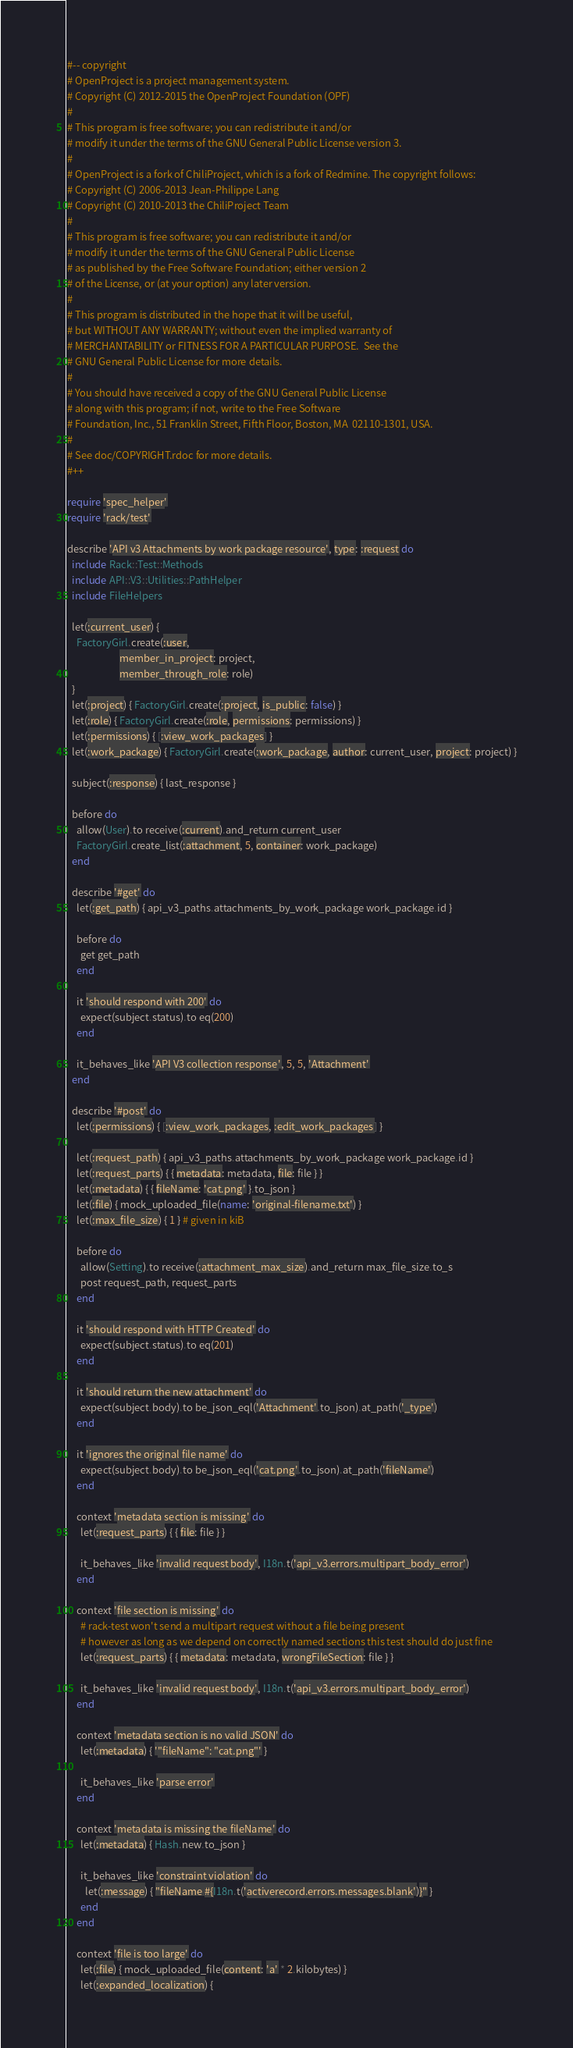<code> <loc_0><loc_0><loc_500><loc_500><_Ruby_>#-- copyright
# OpenProject is a project management system.
# Copyright (C) 2012-2015 the OpenProject Foundation (OPF)
#
# This program is free software; you can redistribute it and/or
# modify it under the terms of the GNU General Public License version 3.
#
# OpenProject is a fork of ChiliProject, which is a fork of Redmine. The copyright follows:
# Copyright (C) 2006-2013 Jean-Philippe Lang
# Copyright (C) 2010-2013 the ChiliProject Team
#
# This program is free software; you can redistribute it and/or
# modify it under the terms of the GNU General Public License
# as published by the Free Software Foundation; either version 2
# of the License, or (at your option) any later version.
#
# This program is distributed in the hope that it will be useful,
# but WITHOUT ANY WARRANTY; without even the implied warranty of
# MERCHANTABILITY or FITNESS FOR A PARTICULAR PURPOSE.  See the
# GNU General Public License for more details.
#
# You should have received a copy of the GNU General Public License
# along with this program; if not, write to the Free Software
# Foundation, Inc., 51 Franklin Street, Fifth Floor, Boston, MA  02110-1301, USA.
#
# See doc/COPYRIGHT.rdoc for more details.
#++

require 'spec_helper'
require 'rack/test'

describe 'API v3 Attachments by work package resource', type: :request do
  include Rack::Test::Methods
  include API::V3::Utilities::PathHelper
  include FileHelpers

  let(:current_user) {
    FactoryGirl.create(:user,
                       member_in_project: project,
                       member_through_role: role)
  }
  let(:project) { FactoryGirl.create(:project, is_public: false) }
  let(:role) { FactoryGirl.create(:role, permissions: permissions) }
  let(:permissions) { [:view_work_packages] }
  let(:work_package) { FactoryGirl.create(:work_package, author: current_user, project: project) }

  subject(:response) { last_response }

  before do
    allow(User).to receive(:current).and_return current_user
    FactoryGirl.create_list(:attachment, 5, container: work_package)
  end

  describe '#get' do
    let(:get_path) { api_v3_paths.attachments_by_work_package work_package.id }

    before do
      get get_path
    end

    it 'should respond with 200' do
      expect(subject.status).to eq(200)
    end

    it_behaves_like 'API V3 collection response', 5, 5, 'Attachment'
  end

  describe '#post' do
    let(:permissions) { [:view_work_packages, :edit_work_packages] }

    let(:request_path) { api_v3_paths.attachments_by_work_package work_package.id }
    let(:request_parts) { { metadata: metadata, file: file } }
    let(:metadata) { { fileName: 'cat.png' }.to_json }
    let(:file) { mock_uploaded_file(name: 'original-filename.txt') }
    let(:max_file_size) { 1 } # given in kiB

    before do
      allow(Setting).to receive(:attachment_max_size).and_return max_file_size.to_s
      post request_path, request_parts
    end

    it 'should respond with HTTP Created' do
      expect(subject.status).to eq(201)
    end

    it 'should return the new attachment' do
      expect(subject.body).to be_json_eql('Attachment'.to_json).at_path('_type')
    end

    it 'ignores the original file name' do
      expect(subject.body).to be_json_eql('cat.png'.to_json).at_path('fileName')
    end

    context 'metadata section is missing' do
      let(:request_parts) { { file: file } }

      it_behaves_like 'invalid request body', I18n.t('api_v3.errors.multipart_body_error')
    end

    context 'file section is missing' do
      # rack-test won't send a multipart request without a file being present
      # however as long as we depend on correctly named sections this test should do just fine
      let(:request_parts) { { metadata: metadata, wrongFileSection: file } }

      it_behaves_like 'invalid request body', I18n.t('api_v3.errors.multipart_body_error')
    end

    context 'metadata section is no valid JSON' do
      let(:metadata) { '"fileName": "cat.png"' }

      it_behaves_like 'parse error'
    end

    context 'metadata is missing the fileName' do
      let(:metadata) { Hash.new.to_json }

      it_behaves_like 'constraint violation' do
        let(:message) { "fileName #{I18n.t('activerecord.errors.messages.blank')}" }
      end
    end

    context 'file is too large' do
      let(:file) { mock_uploaded_file(content: 'a' * 2.kilobytes) }
      let(:expanded_localization) {</code> 